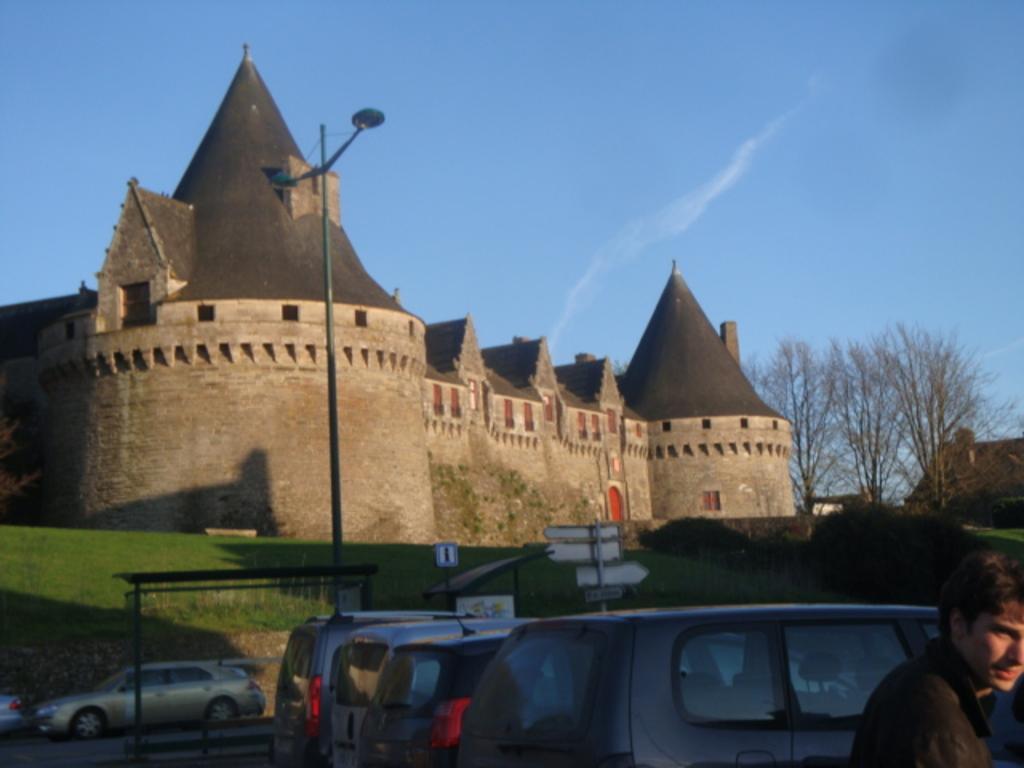Could you give a brief overview of what you see in this image? In this image at front there is a person. Behind him there are cars parked on the road. At the back side there's grass on the surface and we can see street lights, signal board. At the background there are trees, buildings and sky. 